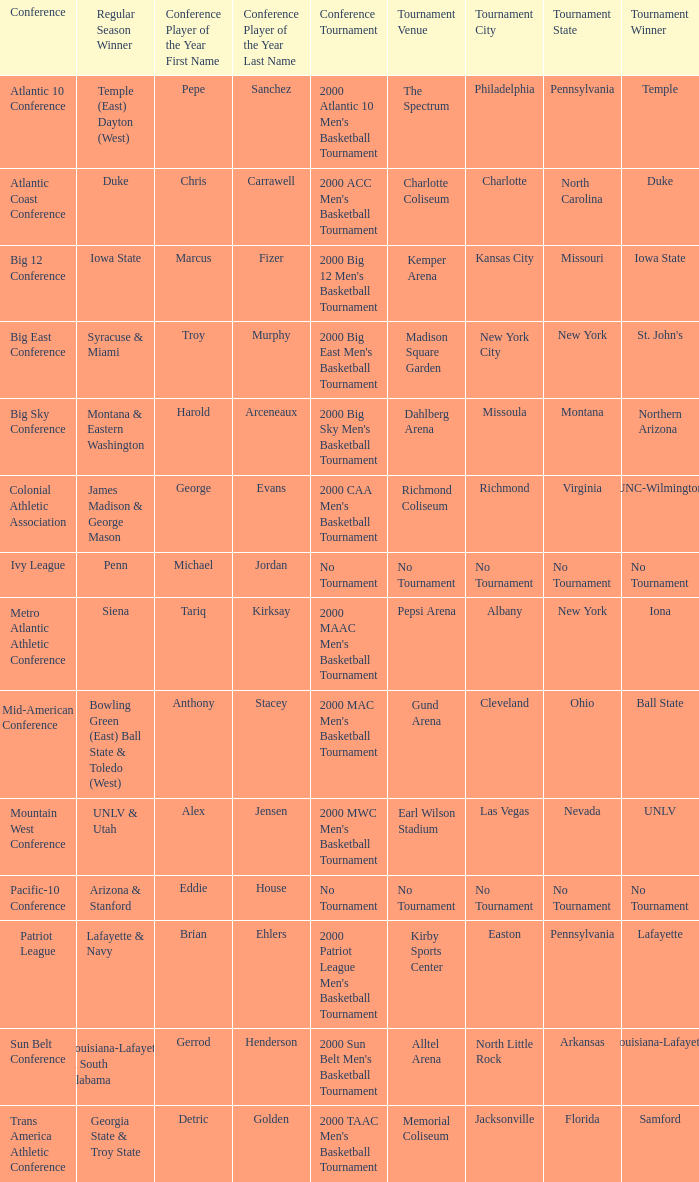In the conference where lafayette emerged as the tournament winner, who was awarded the title of conference player of the year? Brian Ehlers , Lafayette. 